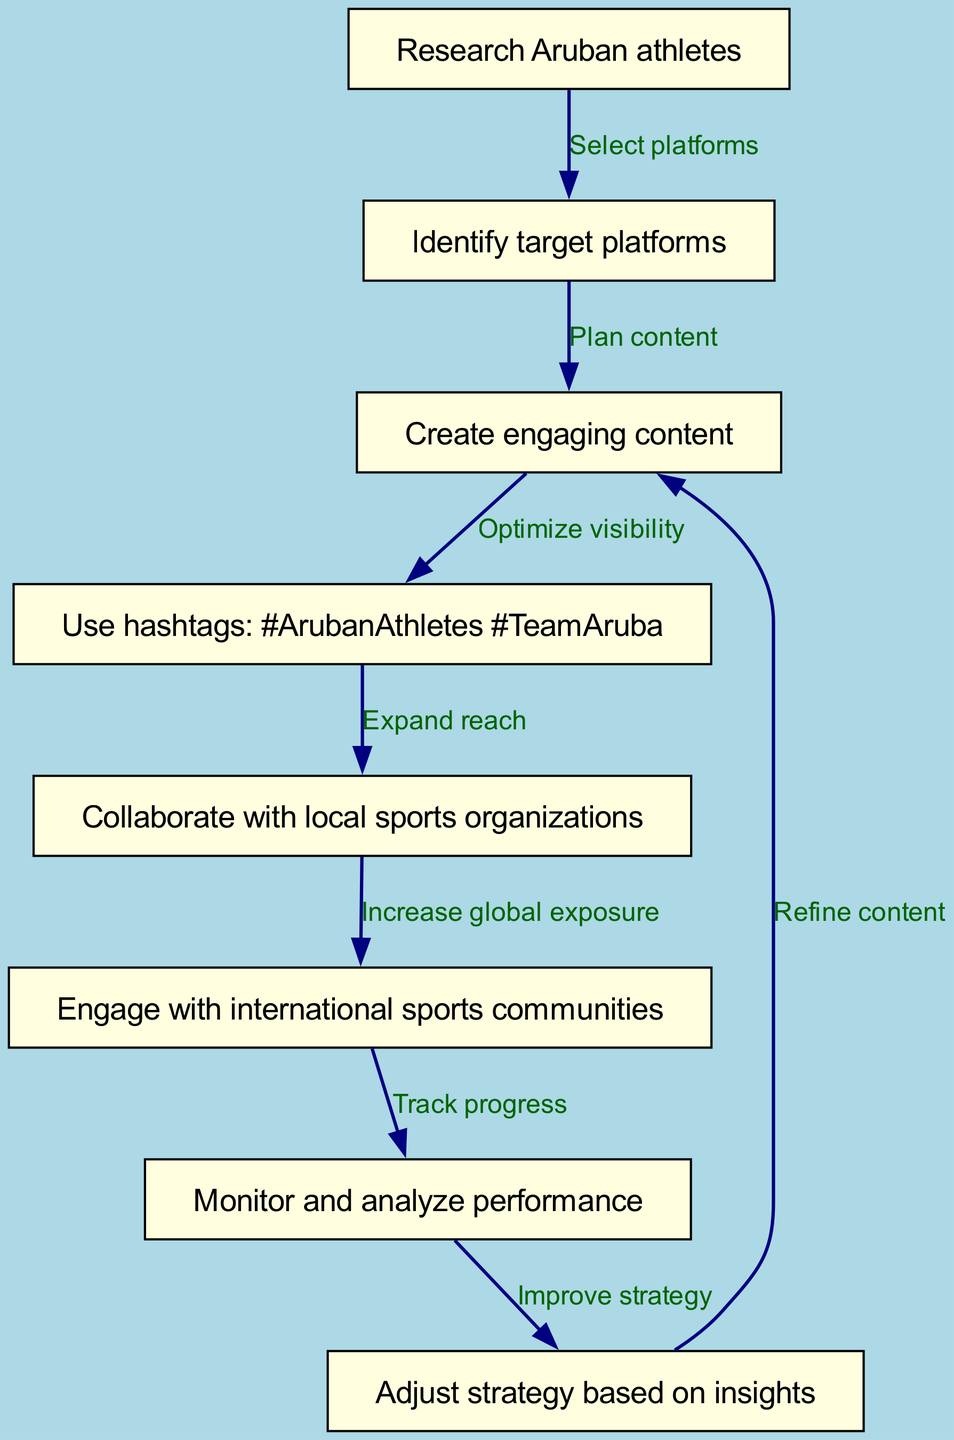What is the total number of nodes in the diagram? The diagram lists eight distinct steps or actions, each represented as a node. Counting these gives a total of eight nodes labeled from research Aruban athletes to adjust strategy based on insights.
Answer: 8 Which node comes after "Create engaging content"? The flow chart indicates that after "Create engaging content," the next step is "Use hashtags: #ArubanAthletes #TeamAruba," as shown by the directed edge connecting these two nodes.
Answer: Use hashtags: #ArubanAthletes #TeamAruba What connects "Identify target platforms" to "Create engaging content"? The diagram shows that the edge labeled "Plan content" connects "Identify target platforms" and "Create engaging content." This indicates that identifying platforms is a precursor to planning the content.
Answer: Plan content How many edges are in the diagram? To determine the number of edges, we can count each connection between the nodes. The flow chart includes seven directed connections, which represent the progression from one step to the next in the workflow.
Answer: 7 What is the final action in the workflow represented in the diagram? The final node in the flow chart shows that the last action is "Adjust strategy based on insights," which concludes the process of creating and implementing the social media strategy.
Answer: Adjust strategy based on insights How do you improve the strategy according to the diagram? The flow chart indicates that after monitoring and analyzing performance, the next step is to adjust the strategy based on the insights gathered from that analysis, pointing towards continual improvement.
Answer: Adjust strategy based on insights Which node is linked to "Engage with international sports communities"? The diagram connects "Engage with international sports communities" to "Monitor and analyze performance," illustrating that engaging with communities is part of the progress leading towards tracking advancement.
Answer: Monitor and analyze performance What is the purpose of using hashtags in the strategy? The diagram explains that using hashtags, specifically #ArubanAthletes and #TeamAruba, is meant to optimize visibility for the content created, effectively increasing engagement and outreach.
Answer: Optimize visibility 